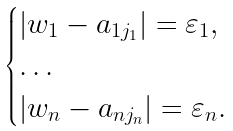<formula> <loc_0><loc_0><loc_500><loc_500>\begin{cases} \left | w _ { 1 } - a _ { 1 j _ { 1 } } \right | = \varepsilon _ { 1 } , \\ \dots \\ \left | w _ { n } - a _ { n j _ { n } } \right | = \varepsilon _ { n } . \end{cases}</formula> 